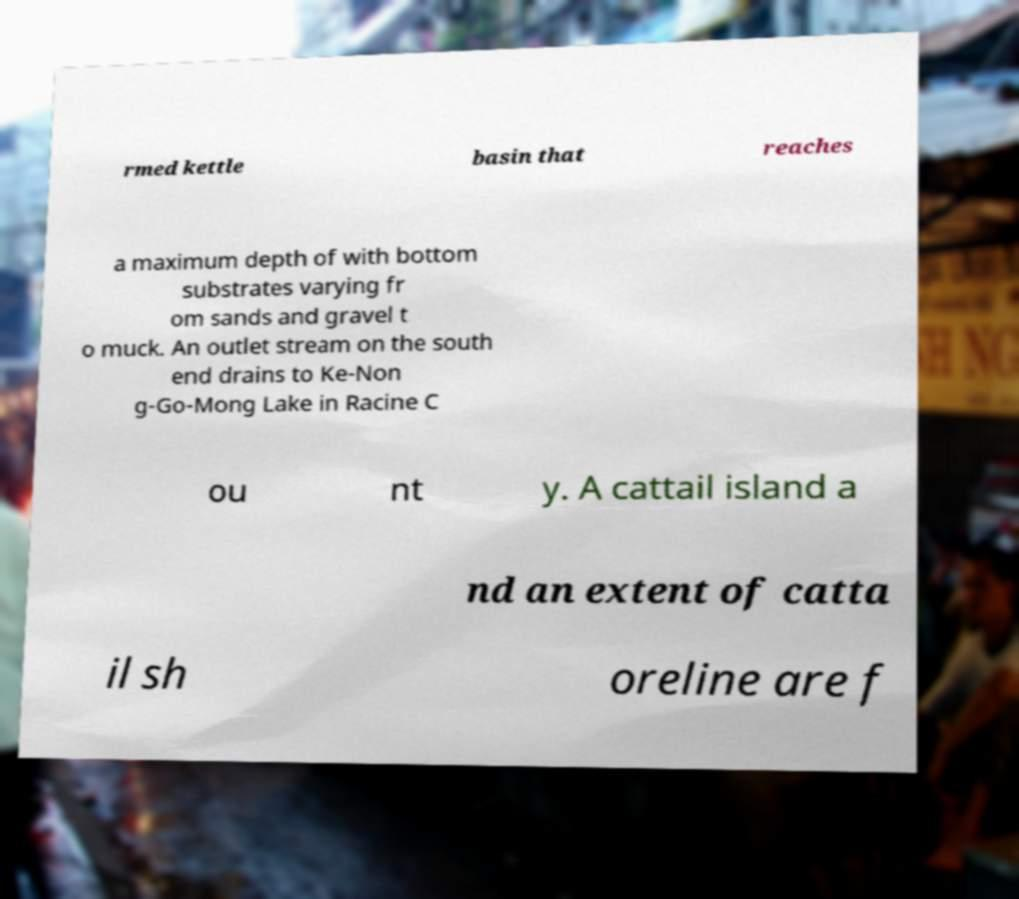For documentation purposes, I need the text within this image transcribed. Could you provide that? rmed kettle basin that reaches a maximum depth of with bottom substrates varying fr om sands and gravel t o muck. An outlet stream on the south end drains to Ke-Non g-Go-Mong Lake in Racine C ou nt y. A cattail island a nd an extent of catta il sh oreline are f 